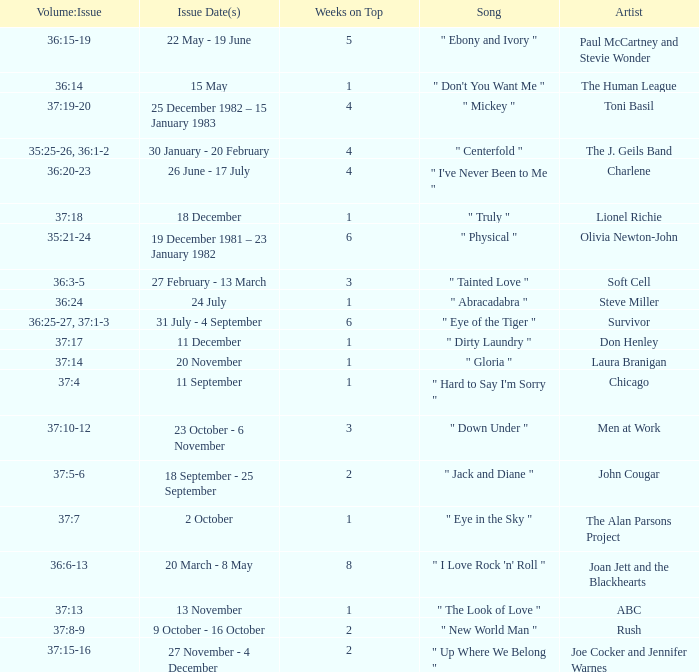Would you mind parsing the complete table? {'header': ['Volume:Issue', 'Issue Date(s)', 'Weeks on Top', 'Song', 'Artist'], 'rows': [['36:15-19', '22 May - 19 June', '5', '" Ebony and Ivory "', 'Paul McCartney and Stevie Wonder'], ['36:14', '15 May', '1', '" Don\'t You Want Me "', 'The Human League'], ['37:19-20', '25 December 1982 – 15 January 1983', '4', '" Mickey "', 'Toni Basil'], ['35:25-26, 36:1-2', '30 January - 20 February', '4', '" Centerfold "', 'The J. Geils Band'], ['36:20-23', '26 June - 17 July', '4', '" I\'ve Never Been to Me "', 'Charlene'], ['37:18', '18 December', '1', '" Truly "', 'Lionel Richie'], ['35:21-24', '19 December 1981 – 23 January 1982', '6', '" Physical "', 'Olivia Newton-John'], ['36:3-5', '27 February - 13 March', '3', '" Tainted Love "', 'Soft Cell'], ['36:24', '24 July', '1', '" Abracadabra "', 'Steve Miller'], ['36:25-27, 37:1-3', '31 July - 4 September', '6', '" Eye of the Tiger "', 'Survivor'], ['37:17', '11 December', '1', '" Dirty Laundry "', 'Don Henley'], ['37:14', '20 November', '1', '" Gloria "', 'Laura Branigan'], ['37:4', '11 September', '1', '" Hard to Say I\'m Sorry "', 'Chicago'], ['37:10-12', '23 October - 6 November', '3', '" Down Under "', 'Men at Work'], ['37:5-6', '18 September - 25 September', '2', '" Jack and Diane "', 'John Cougar'], ['37:7', '2 October', '1', '" Eye in the Sky "', 'The Alan Parsons Project'], ['36:6-13', '20 March - 8 May', '8', '" I Love Rock \'n\' Roll "', 'Joan Jett and the Blackhearts'], ['37:13', '13 November', '1', '" The Look of Love "', 'ABC'], ['37:8-9', '9 October - 16 October', '2', '" New World Man "', 'Rush'], ['37:15-16', '27 November - 4 December', '2', '" Up Where We Belong "', 'Joe Cocker and Jennifer Warnes']]} Which Weeks on Top have an Issue Date(s) of 20 november? 1.0. 